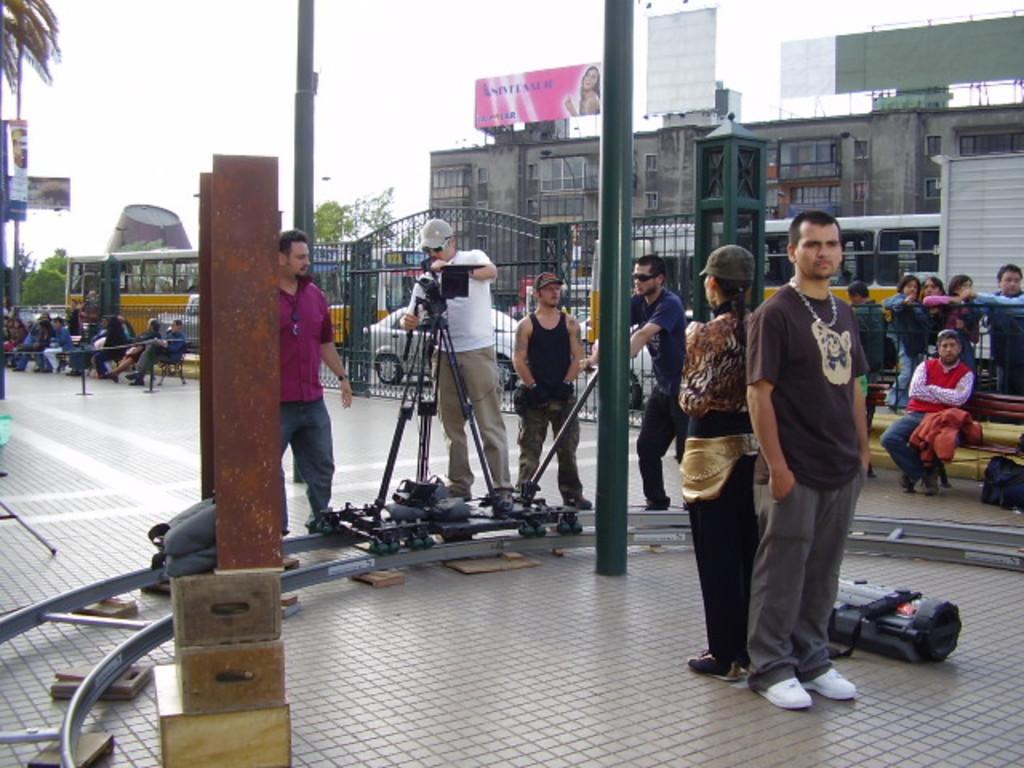How would you summarize this image in a sentence or two? In the image there are few persons standing around a camera track, in the back there are many people standing and sitting behind the fence and over the background there are buildings with vehicles going in front of it on the road and above its sky. 